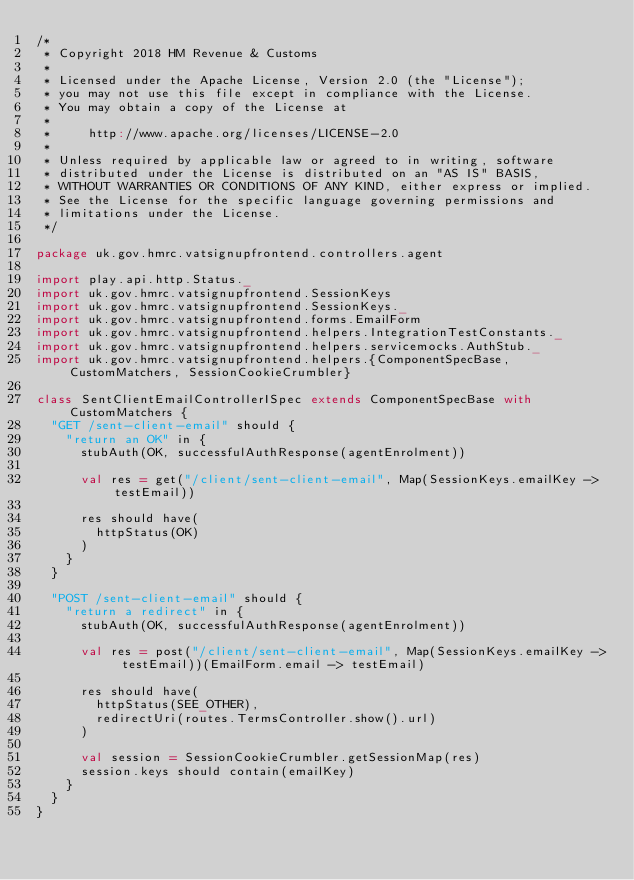Convert code to text. <code><loc_0><loc_0><loc_500><loc_500><_Scala_>/*
 * Copyright 2018 HM Revenue & Customs
 *
 * Licensed under the Apache License, Version 2.0 (the "License");
 * you may not use this file except in compliance with the License.
 * You may obtain a copy of the License at
 *
 *     http://www.apache.org/licenses/LICENSE-2.0
 *
 * Unless required by applicable law or agreed to in writing, software
 * distributed under the License is distributed on an "AS IS" BASIS,
 * WITHOUT WARRANTIES OR CONDITIONS OF ANY KIND, either express or implied.
 * See the License for the specific language governing permissions and
 * limitations under the License.
 */

package uk.gov.hmrc.vatsignupfrontend.controllers.agent

import play.api.http.Status._
import uk.gov.hmrc.vatsignupfrontend.SessionKeys
import uk.gov.hmrc.vatsignupfrontend.SessionKeys._
import uk.gov.hmrc.vatsignupfrontend.forms.EmailForm
import uk.gov.hmrc.vatsignupfrontend.helpers.IntegrationTestConstants._
import uk.gov.hmrc.vatsignupfrontend.helpers.servicemocks.AuthStub._
import uk.gov.hmrc.vatsignupfrontend.helpers.{ComponentSpecBase, CustomMatchers, SessionCookieCrumbler}

class SentClientEmailControllerISpec extends ComponentSpecBase with CustomMatchers {
  "GET /sent-client-email" should {
    "return an OK" in {
      stubAuth(OK, successfulAuthResponse(agentEnrolment))

      val res = get("/client/sent-client-email", Map(SessionKeys.emailKey -> testEmail))

      res should have(
        httpStatus(OK)
      )
    }
  }

  "POST /sent-client-email" should {
    "return a redirect" in {
      stubAuth(OK, successfulAuthResponse(agentEnrolment))

      val res = post("/client/sent-client-email", Map(SessionKeys.emailKey -> testEmail))(EmailForm.email -> testEmail)

      res should have(
        httpStatus(SEE_OTHER),
        redirectUri(routes.TermsController.show().url)
      )

      val session = SessionCookieCrumbler.getSessionMap(res)
      session.keys should contain(emailKey)
    }
  }
}
</code> 